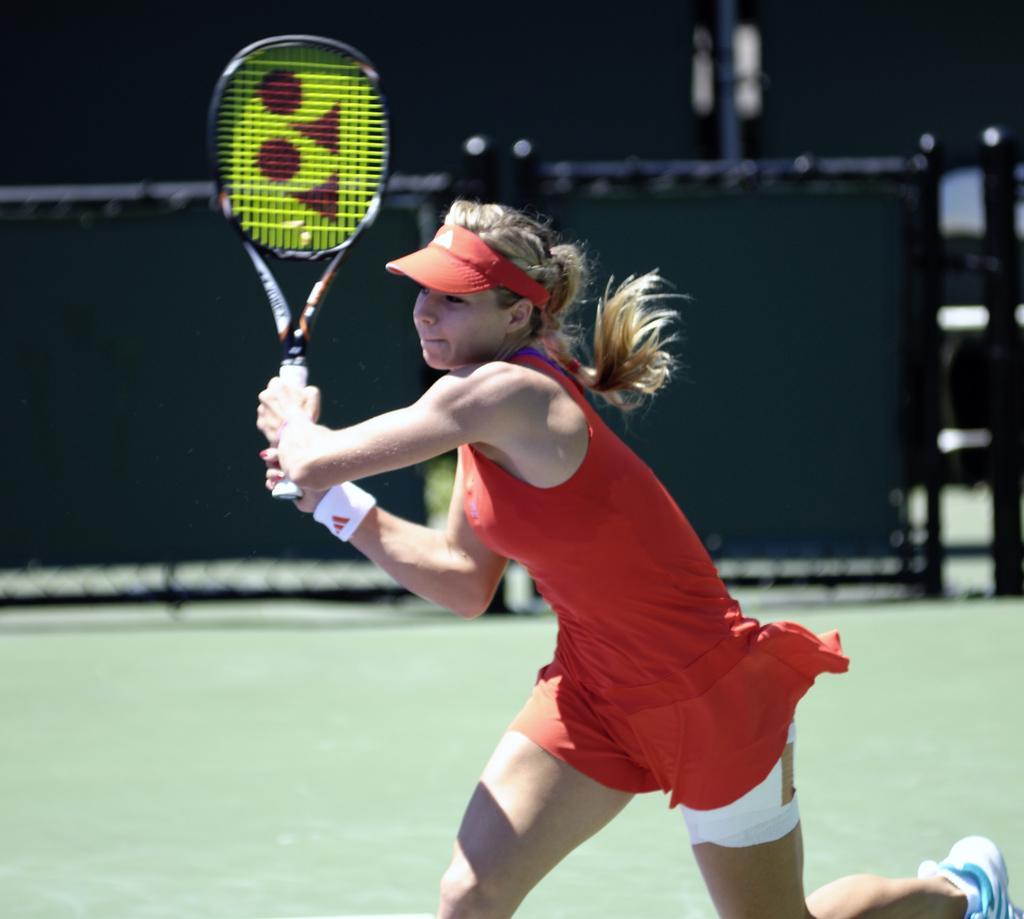Describe this image in one or two sentences. In this picture we can see a woman who is holding a racket with her hands. And this is ground. 